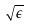<formula> <loc_0><loc_0><loc_500><loc_500>\sqrt { \epsilon }</formula> 